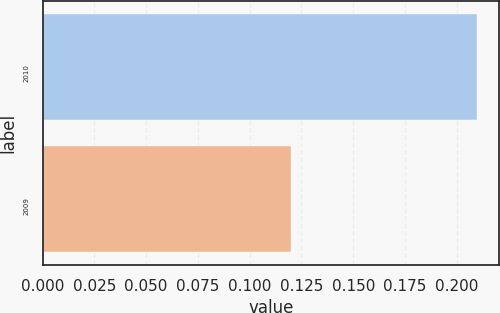Convert chart to OTSL. <chart><loc_0><loc_0><loc_500><loc_500><bar_chart><fcel>2010<fcel>2009<nl><fcel>0.21<fcel>0.12<nl></chart> 